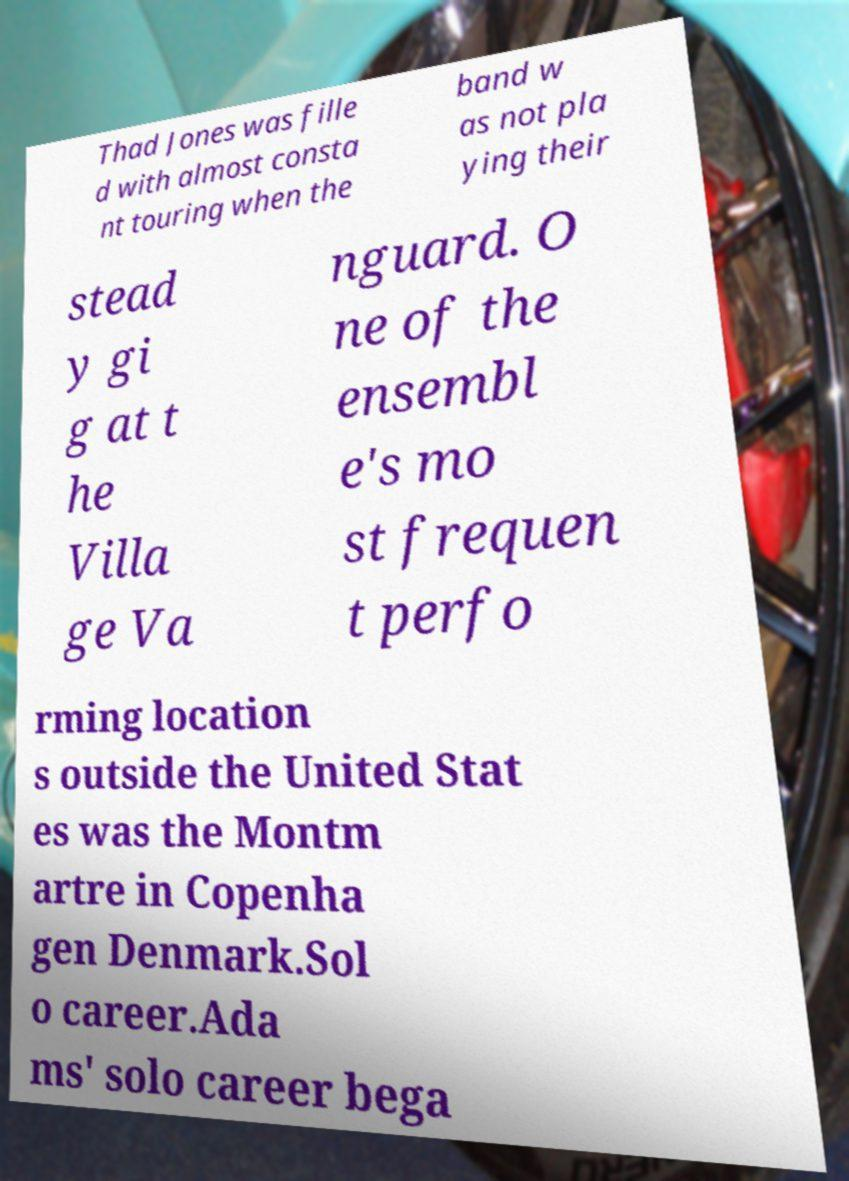Please identify and transcribe the text found in this image. Thad Jones was fille d with almost consta nt touring when the band w as not pla ying their stead y gi g at t he Villa ge Va nguard. O ne of the ensembl e's mo st frequen t perfo rming location s outside the United Stat es was the Montm artre in Copenha gen Denmark.Sol o career.Ada ms' solo career bega 